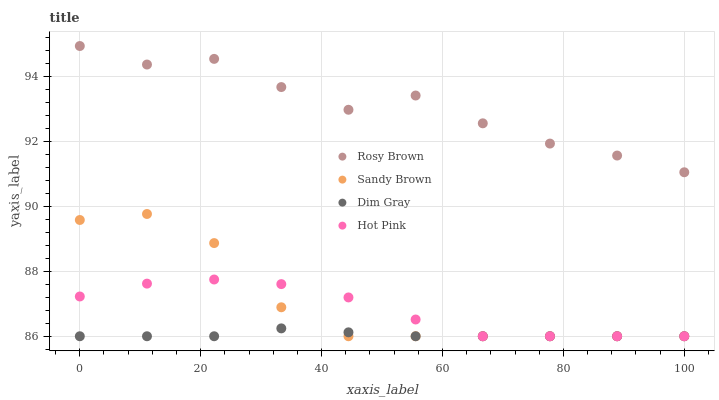Does Dim Gray have the minimum area under the curve?
Answer yes or no. Yes. Does Rosy Brown have the maximum area under the curve?
Answer yes or no. Yes. Does Sandy Brown have the minimum area under the curve?
Answer yes or no. No. Does Sandy Brown have the maximum area under the curve?
Answer yes or no. No. Is Dim Gray the smoothest?
Answer yes or no. Yes. Is Rosy Brown the roughest?
Answer yes or no. Yes. Is Sandy Brown the smoothest?
Answer yes or no. No. Is Sandy Brown the roughest?
Answer yes or no. No. Does Dim Gray have the lowest value?
Answer yes or no. Yes. Does Rosy Brown have the lowest value?
Answer yes or no. No. Does Rosy Brown have the highest value?
Answer yes or no. Yes. Does Sandy Brown have the highest value?
Answer yes or no. No. Is Dim Gray less than Rosy Brown?
Answer yes or no. Yes. Is Rosy Brown greater than Hot Pink?
Answer yes or no. Yes. Does Hot Pink intersect Dim Gray?
Answer yes or no. Yes. Is Hot Pink less than Dim Gray?
Answer yes or no. No. Is Hot Pink greater than Dim Gray?
Answer yes or no. No. Does Dim Gray intersect Rosy Brown?
Answer yes or no. No. 